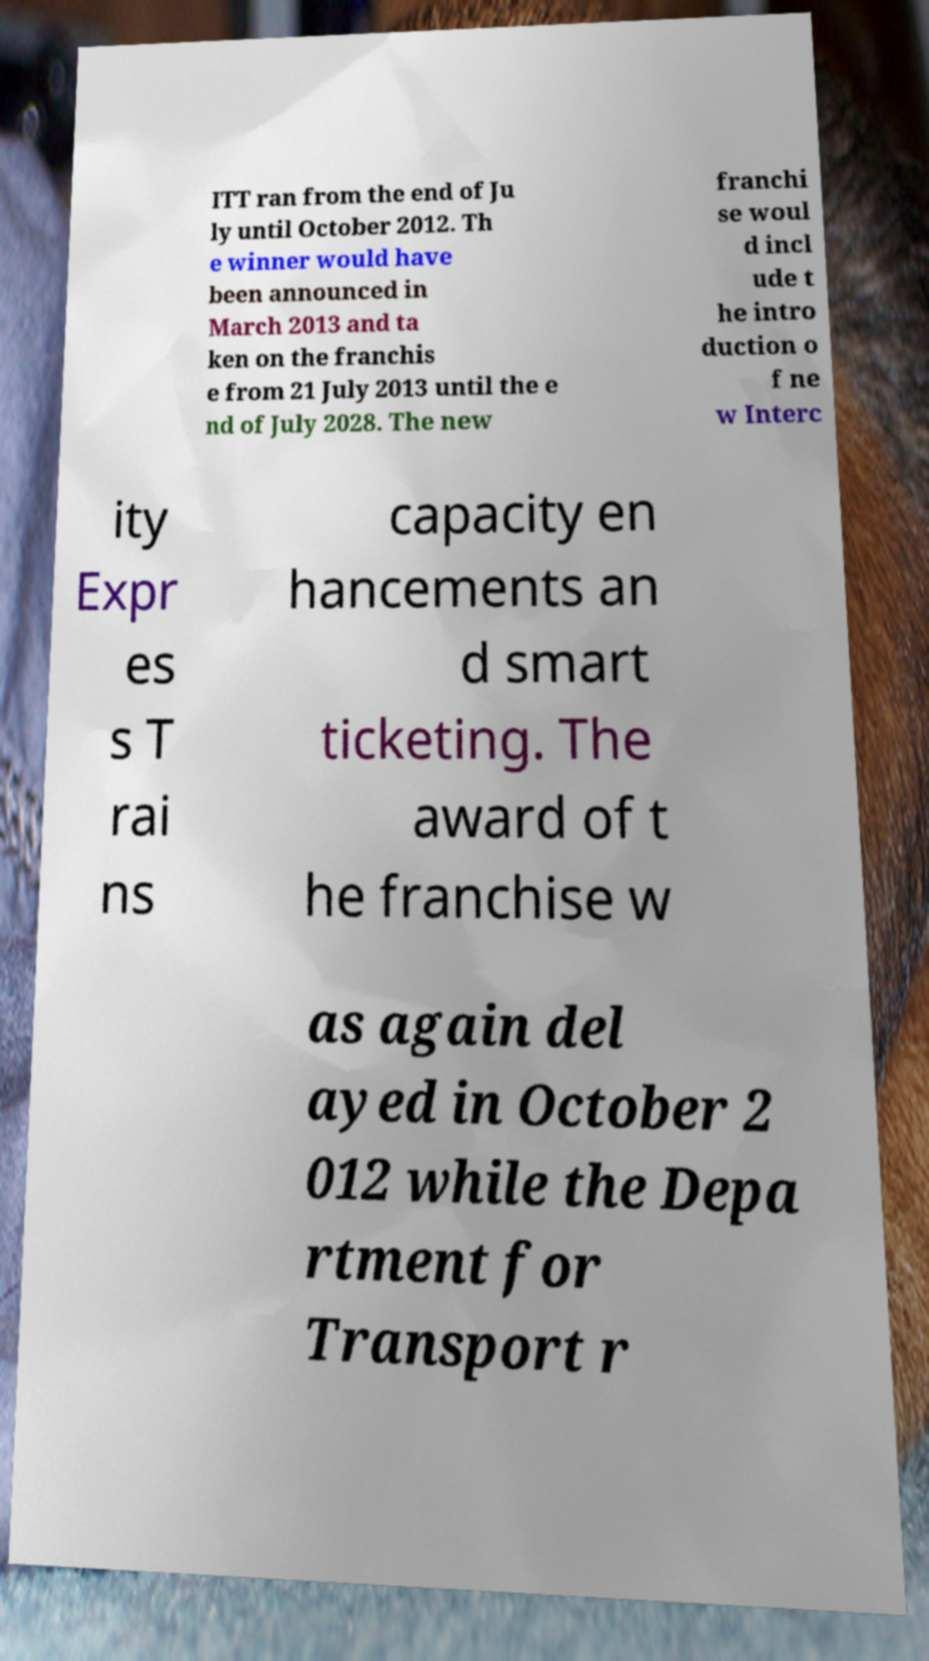For documentation purposes, I need the text within this image transcribed. Could you provide that? ITT ran from the end of Ju ly until October 2012. Th e winner would have been announced in March 2013 and ta ken on the franchis e from 21 July 2013 until the e nd of July 2028. The new franchi se woul d incl ude t he intro duction o f ne w Interc ity Expr es s T rai ns capacity en hancements an d smart ticketing. The award of t he franchise w as again del ayed in October 2 012 while the Depa rtment for Transport r 